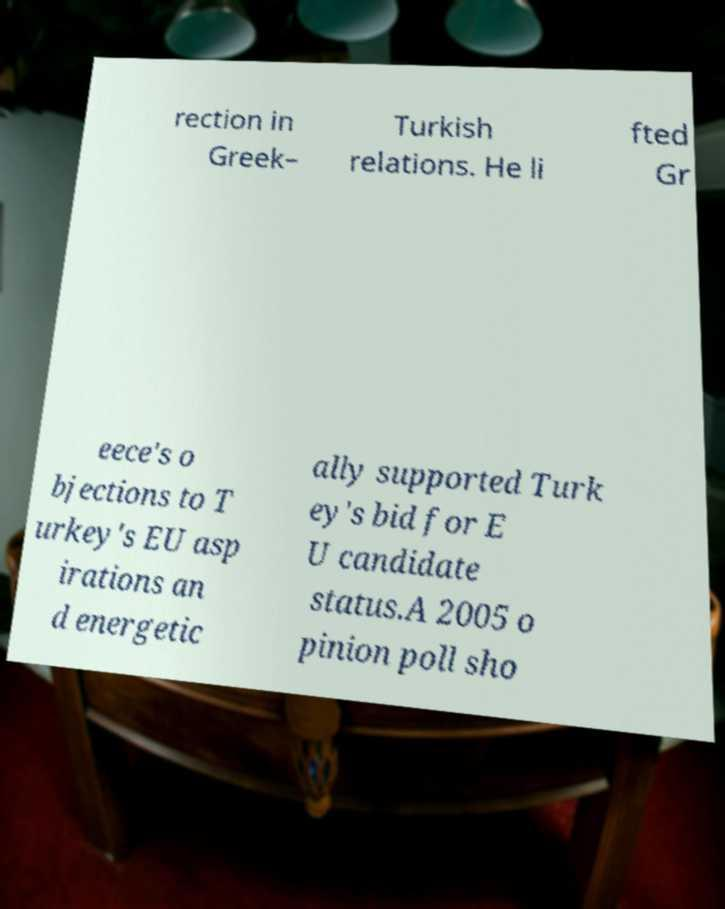Can you read and provide the text displayed in the image?This photo seems to have some interesting text. Can you extract and type it out for me? rection in Greek– Turkish relations. He li fted Gr eece's o bjections to T urkey's EU asp irations an d energetic ally supported Turk ey's bid for E U candidate status.A 2005 o pinion poll sho 